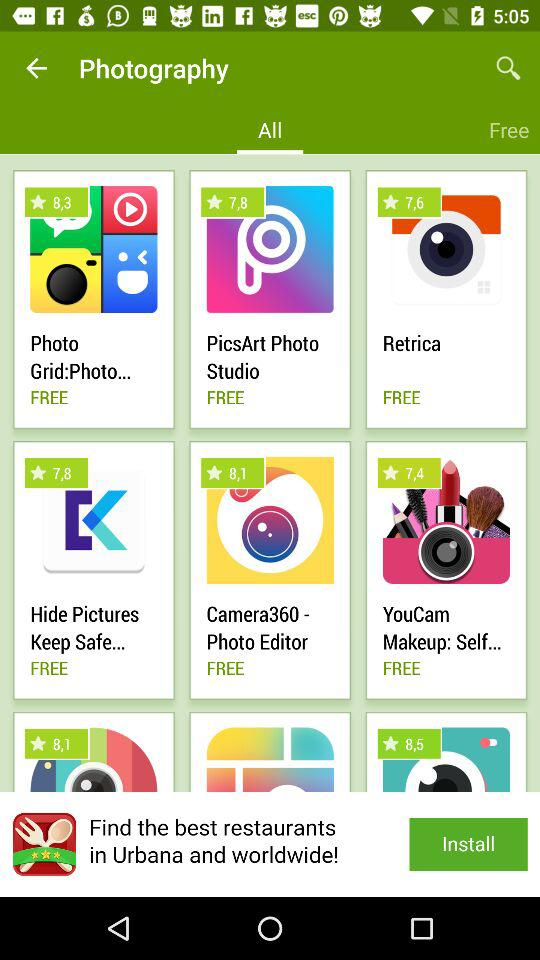What is the rating for the "PicsArt Photo Studio" app? The rating for the "PicsArt Photo Studio" app is 7.8. 